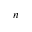Convert formula to latex. <formula><loc_0><loc_0><loc_500><loc_500>n</formula> 